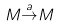Convert formula to latex. <formula><loc_0><loc_0><loc_500><loc_500>M { \stackrel { a } { \to } } M</formula> 